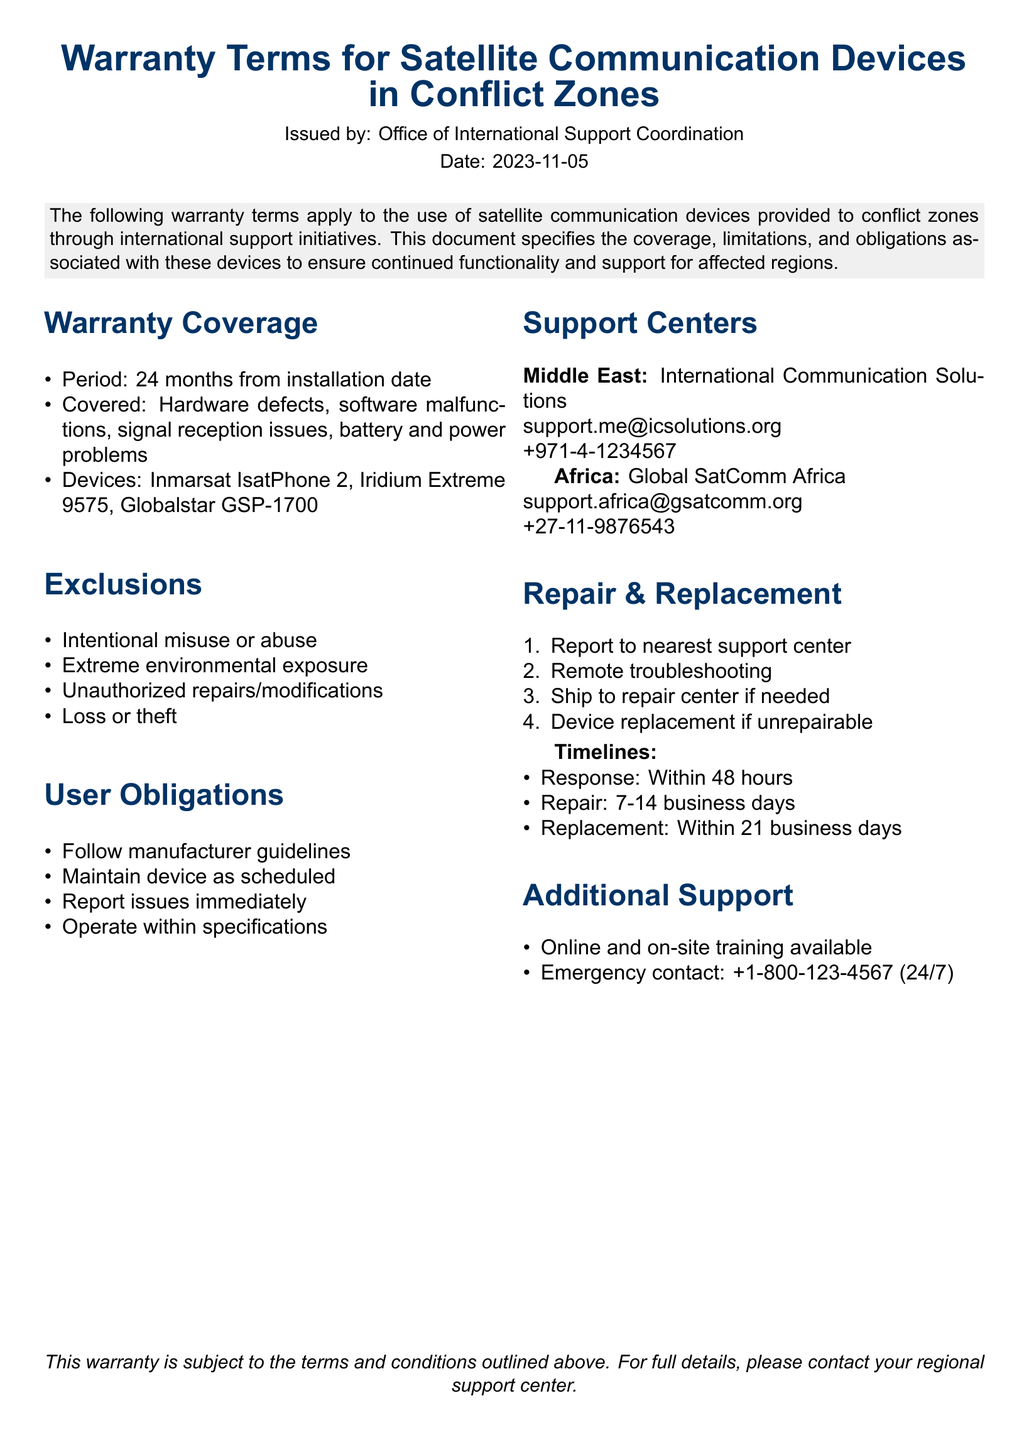What is the warranty period? The warranty period is defined as the time frame during which coverage is applicable, stated as 24 months from the installation date.
Answer: 24 months Which devices are covered under the warranty? The document lists specific satellite communication devices that are eligible for warranty coverage, which includes the Inmarsat IsatPhone 2, Iridium Extreme 9575, and Globalstar GSP-1700.
Answer: Inmarsat IsatPhone 2, Iridium Extreme 9575, Globalstar GSP-1700 What should users do immediately upon discovering an issue? User obligations outline what actions should be taken, specifically mentioning that issues should be reported immediately after they are discovered.
Answer: Report issues immediately What is excluded from the warranty coverage? The document specifies certain conditions under which the warranty does not apply, including intentional misuse or abuse.
Answer: Intentional misuse or abuse What is the response time for support? The document provides a timeline for support response, indicating that the support team will respond within a specific time frame after a report is made.
Answer: Within 48 hours Where is the support center in Africa located? The document mentions a specific support center in Africa, giving the name and contact details for users in that region.
Answer: Global SatComm Africa What happens if a device is unrepairable? The repair and replacement section states the protocol if a device cannot be repaired, which includes a process for providing a replacement.
Answer: Device replacement if unrepairable How long does repair take? Timelines for repairs are provided, indicating the typical duration for repairs to be completed following a troubleshooting report.
Answer: 7-14 business days What training options are available for users? The document lists additional support options available, including training methods for users to get accustomed to the devices provided.
Answer: Online and on-site training available 